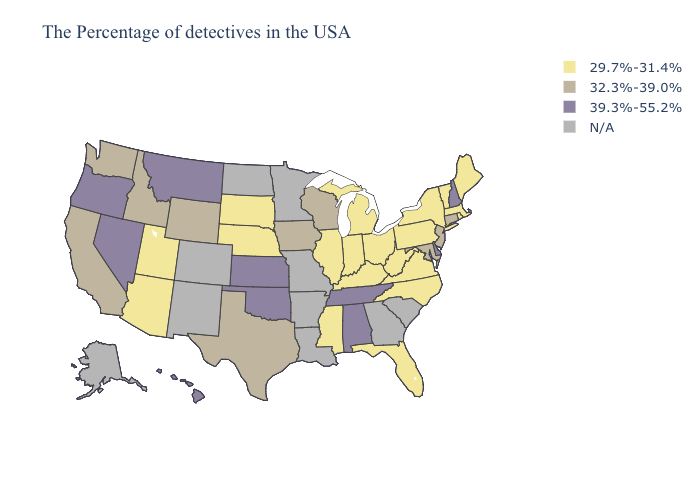What is the value of Mississippi?
Keep it brief. 29.7%-31.4%. Does New Hampshire have the highest value in the Northeast?
Quick response, please. Yes. What is the highest value in the USA?
Concise answer only. 39.3%-55.2%. What is the value of Nebraska?
Give a very brief answer. 29.7%-31.4%. Among the states that border Arkansas , does Texas have the lowest value?
Write a very short answer. No. Name the states that have a value in the range 29.7%-31.4%?
Give a very brief answer. Maine, Massachusetts, Rhode Island, Vermont, New York, Pennsylvania, Virginia, North Carolina, West Virginia, Ohio, Florida, Michigan, Kentucky, Indiana, Illinois, Mississippi, Nebraska, South Dakota, Utah, Arizona. Which states hav the highest value in the Northeast?
Short answer required. New Hampshire. Does the map have missing data?
Be succinct. Yes. What is the value of Connecticut?
Quick response, please. 32.3%-39.0%. What is the value of Minnesota?
Write a very short answer. N/A. What is the highest value in the West ?
Answer briefly. 39.3%-55.2%. 